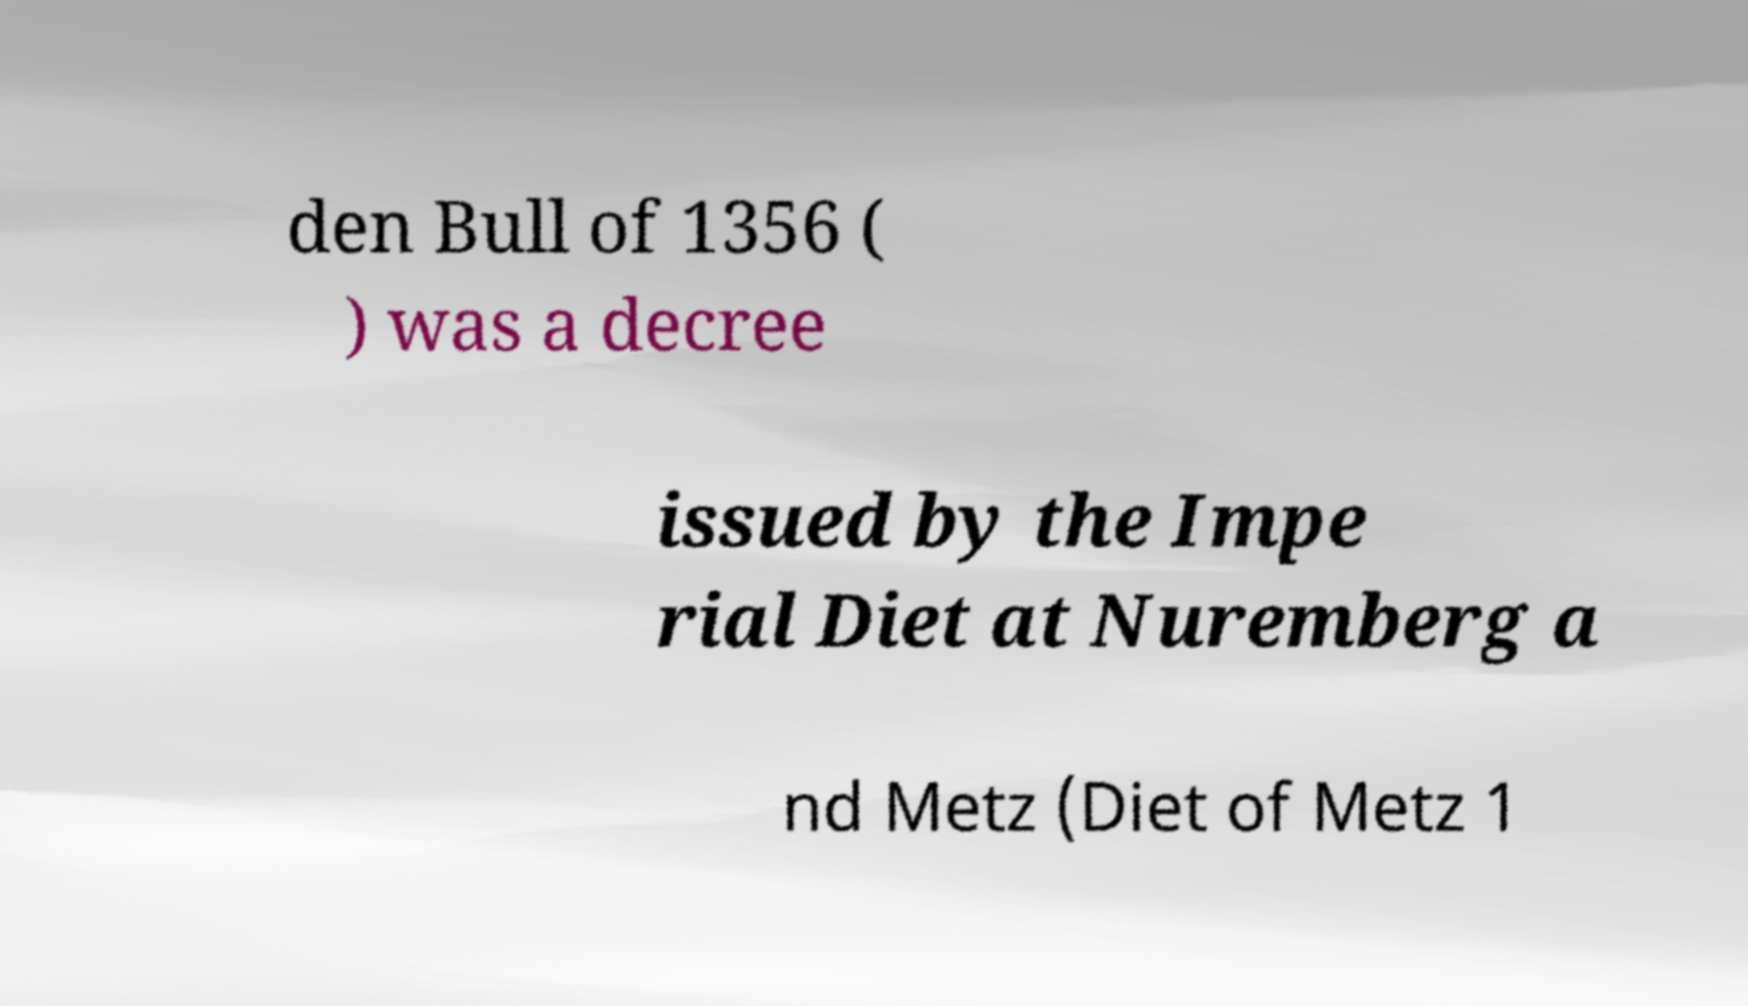Please read and relay the text visible in this image. What does it say? den Bull of 1356 ( ) was a decree issued by the Impe rial Diet at Nuremberg a nd Metz (Diet of Metz 1 